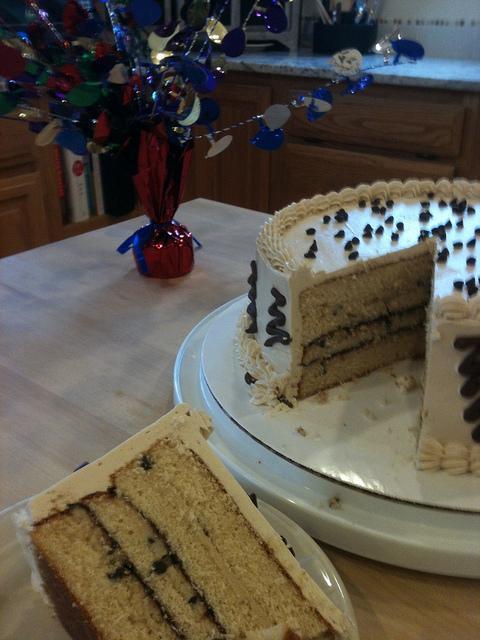How many dining tables are there?
Give a very brief answer. 1. How many cakes are visible?
Give a very brief answer. 2. 